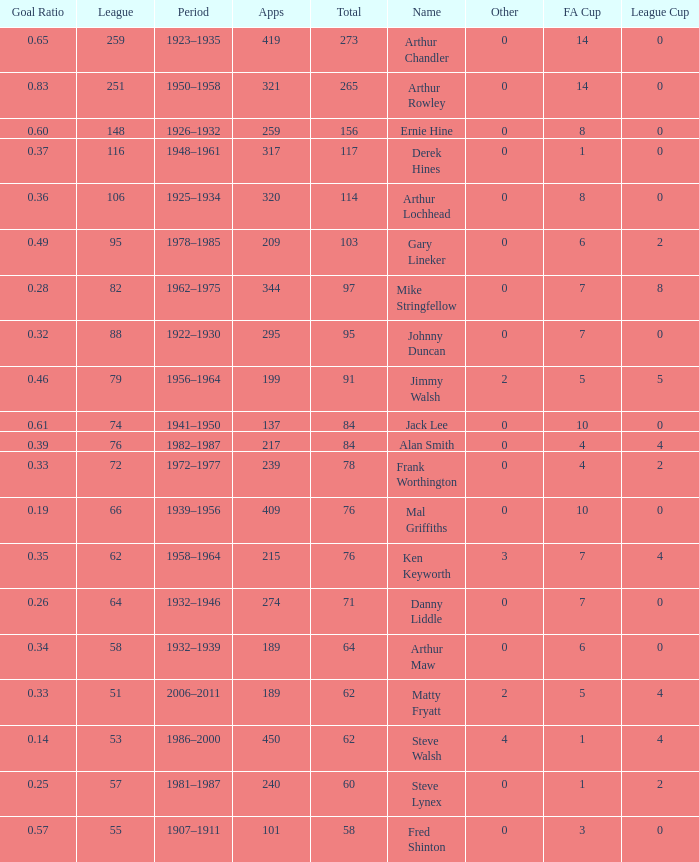What's the highest FA Cup with the Name of Alan Smith, and League Cup smaller than 4? None. Can you give me this table as a dict? {'header': ['Goal Ratio', 'League', 'Period', 'Apps', 'Total', 'Name', 'Other', 'FA Cup', 'League Cup'], 'rows': [['0.65', '259', '1923–1935', '419', '273', 'Arthur Chandler', '0', '14', '0'], ['0.83', '251', '1950–1958', '321', '265', 'Arthur Rowley', '0', '14', '0'], ['0.60', '148', '1926–1932', '259', '156', 'Ernie Hine', '0', '8', '0'], ['0.37', '116', '1948–1961', '317', '117', 'Derek Hines', '0', '1', '0'], ['0.36', '106', '1925–1934', '320', '114', 'Arthur Lochhead', '0', '8', '0'], ['0.49', '95', '1978–1985', '209', '103', 'Gary Lineker', '0', '6', '2'], ['0.28', '82', '1962–1975', '344', '97', 'Mike Stringfellow', '0', '7', '8'], ['0.32', '88', '1922–1930', '295', '95', 'Johnny Duncan', '0', '7', '0'], ['0.46', '79', '1956–1964', '199', '91', 'Jimmy Walsh', '2', '5', '5'], ['0.61', '74', '1941–1950', '137', '84', 'Jack Lee', '0', '10', '0'], ['0.39', '76', '1982–1987', '217', '84', 'Alan Smith', '0', '4', '4'], ['0.33', '72', '1972–1977', '239', '78', 'Frank Worthington', '0', '4', '2'], ['0.19', '66', '1939–1956', '409', '76', 'Mal Griffiths', '0', '10', '0'], ['0.35', '62', '1958–1964', '215', '76', 'Ken Keyworth', '3', '7', '4'], ['0.26', '64', '1932–1946', '274', '71', 'Danny Liddle', '0', '7', '0'], ['0.34', '58', '1932–1939', '189', '64', 'Arthur Maw', '0', '6', '0'], ['0.33', '51', '2006–2011', '189', '62', 'Matty Fryatt', '2', '5', '4'], ['0.14', '53', '1986–2000', '450', '62', 'Steve Walsh', '4', '1', '4'], ['0.25', '57', '1981–1987', '240', '60', 'Steve Lynex', '0', '1', '2'], ['0.57', '55', '1907–1911', '101', '58', 'Fred Shinton', '0', '3', '0']]} 